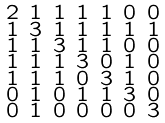<formula> <loc_0><loc_0><loc_500><loc_500>\begin{smallmatrix} 2 & 1 & 1 & 1 & 1 & 0 & 0 \\ 1 & 3 & 1 & 1 & 1 & 1 & 1 \\ 1 & 1 & 3 & 1 & 1 & 0 & 0 \\ 1 & 1 & 1 & 3 & 0 & 1 & 0 \\ 1 & 1 & 1 & 0 & 3 & 1 & 0 \\ 0 & 1 & 0 & 1 & 1 & 3 & 0 \\ 0 & 1 & 0 & 0 & 0 & 0 & 3 \end{smallmatrix}</formula> 